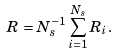Convert formula to latex. <formula><loc_0><loc_0><loc_500><loc_500>R = N _ { s } ^ { - 1 } \sum _ { i = 1 } ^ { N _ { s } } R _ { i } .</formula> 